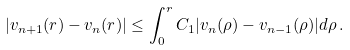<formula> <loc_0><loc_0><loc_500><loc_500>| v _ { n + 1 } ( r ) - v _ { n } ( r ) | \leq \int _ { 0 } ^ { r } C _ { 1 } | v _ { n } ( \rho ) - v _ { n - 1 } ( \rho ) | d \rho \, .</formula> 